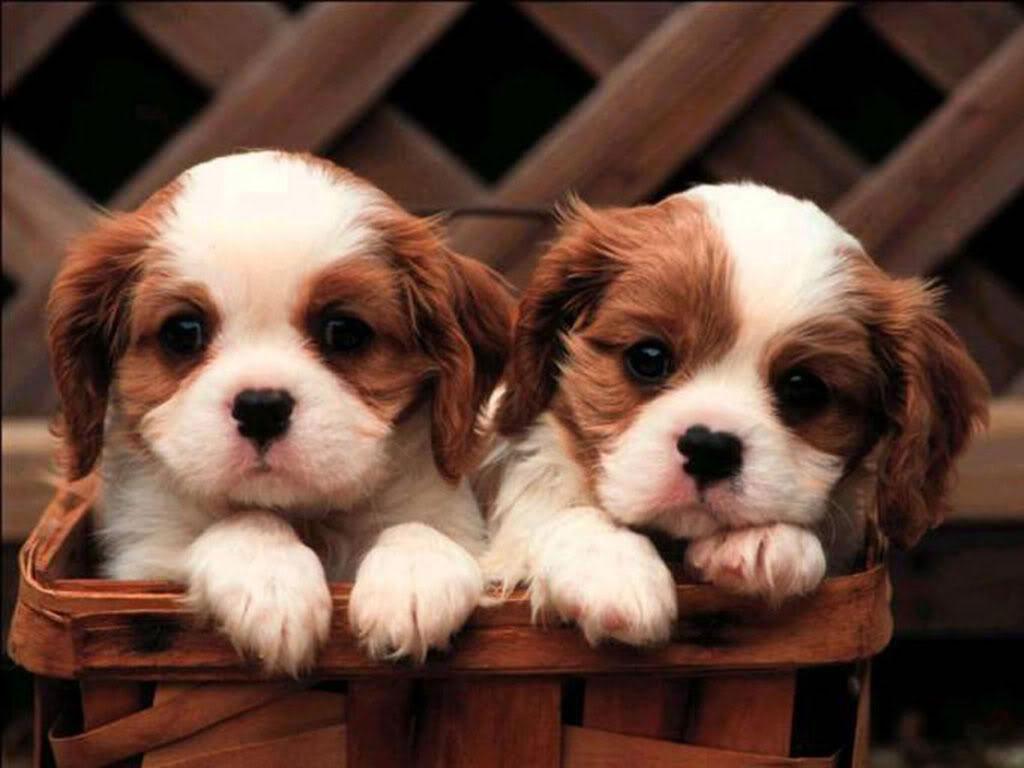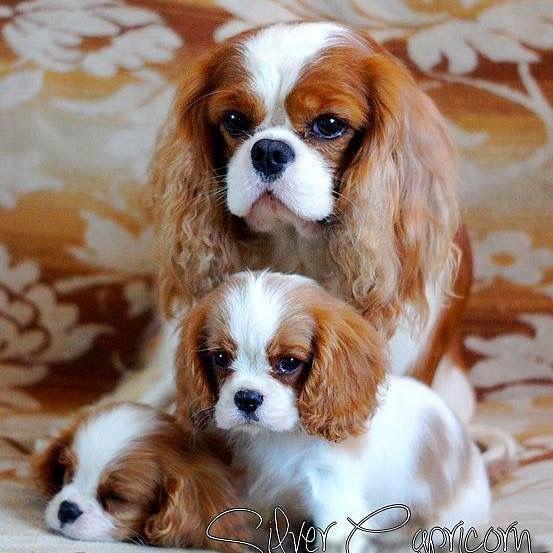The first image is the image on the left, the second image is the image on the right. Examine the images to the left and right. Is the description "There is exactly three dogs in the right image." accurate? Answer yes or no. Yes. The first image is the image on the left, the second image is the image on the right. Examine the images to the left and right. Is the description "There are three dogs in one image and two in another." accurate? Answer yes or no. Yes. 